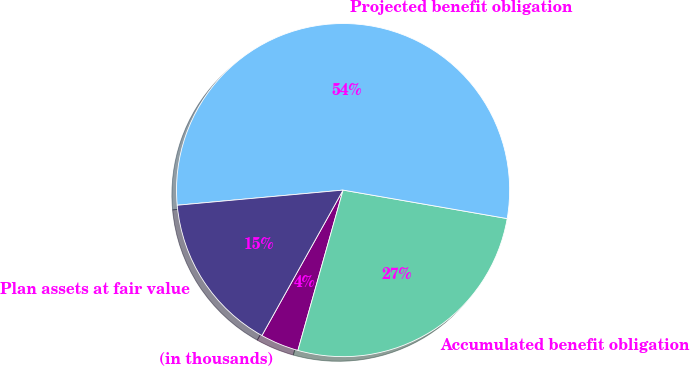Convert chart. <chart><loc_0><loc_0><loc_500><loc_500><pie_chart><fcel>(in thousands)<fcel>Accumulated benefit obligation<fcel>Projected benefit obligation<fcel>Plan assets at fair value<nl><fcel>3.73%<fcel>26.64%<fcel>54.19%<fcel>15.45%<nl></chart> 